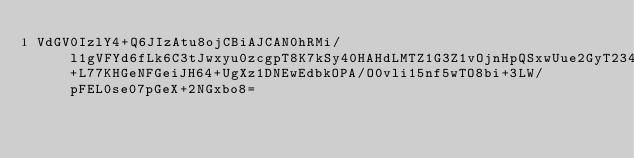<code> <loc_0><loc_0><loc_500><loc_500><_SML_>VdGV0IzlY4+Q6JIzAtu8ojCBiAJCAN0hRMi/l1gVFYd6fLk6C3tJwxyu0zcgpT8K7kSy40HAHdLMTZ1G3Z1vOjnHpQSxwUue2GyT2349fwne4bsSR75CAkIBoE7iMjfAP9+L77KHGeNFGeiJH64+UgXz1DNEwEdbkOPA/O0vli15nf5wTO8bi+3LW/pFEL0se07pGeX+2NGxbo8=</code> 